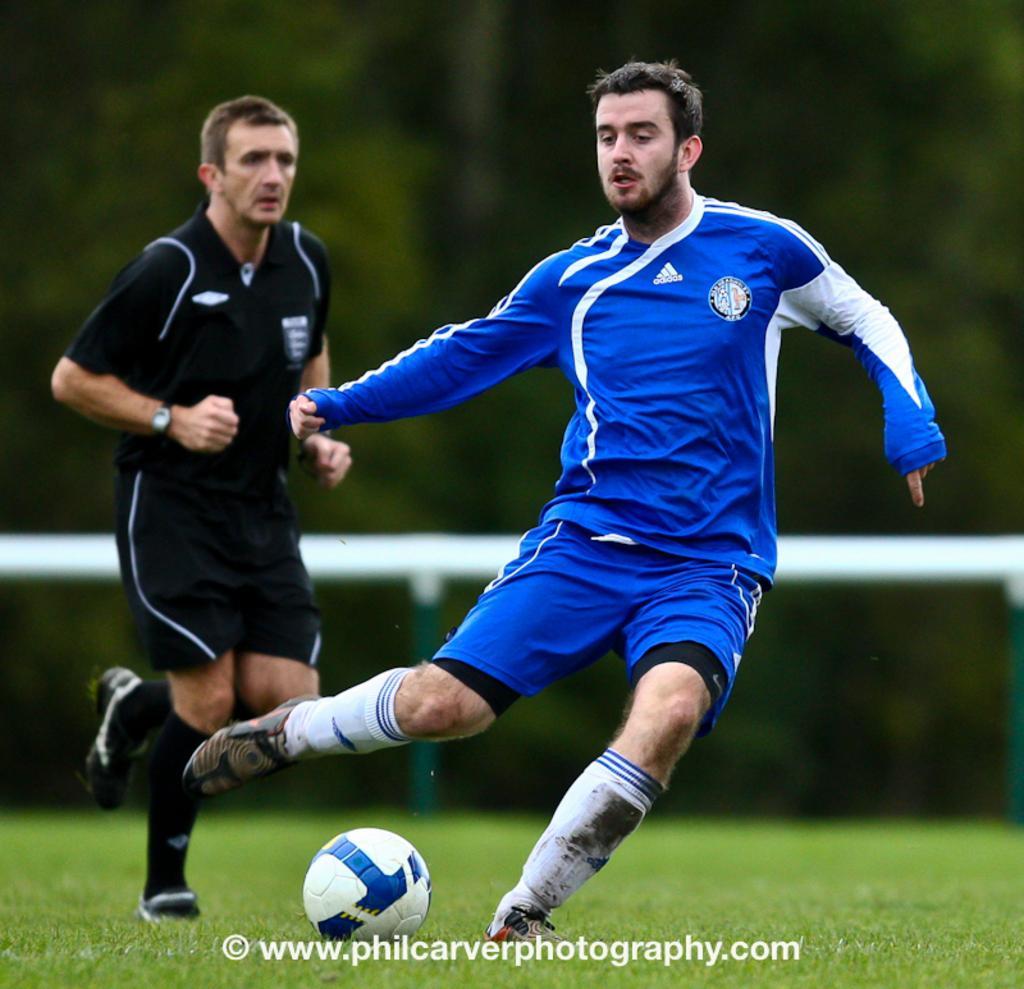Can you describe this image briefly? In this image we can see two persons. On the ground there is grass and a ball. In the background it is looking blur. At the bottom something is written. 